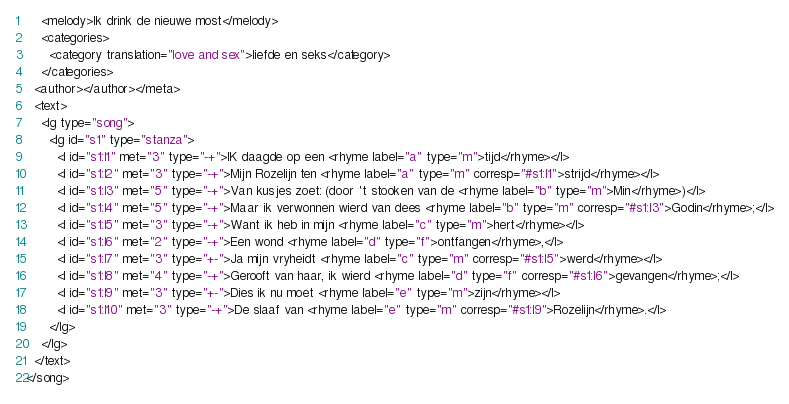<code> <loc_0><loc_0><loc_500><loc_500><_XML_>    <melody>Ik drink de nieuwe most</melody>
    <categories>
      <category translation="love and sex">liefde en seks</category>
    </categories>
  <author></author></meta>
  <text>
    <lg type="song">
      <lg id="s1" type="stanza">
        <l id="s1:l1" met="3" type="-+">IK daagde op een <rhyme label="a" type="m">tijd</rhyme></l>
        <l id="s1:l2" met="3" type="-+">Mijn Rozelijn ten <rhyme label="a" type="m" corresp="#s1:l1">strijd</rhyme></l>
        <l id="s1:l3" met="5" type="-+">Van kusjes zoet: (door 't stooken van de <rhyme label="b" type="m">Min</rhyme>)</l>
        <l id="s1:l4" met="5" type="-+">Maar ik verwonnen wierd van dees <rhyme label="b" type="m" corresp="#s1:l3">Godin</rhyme>;</l>
        <l id="s1:l5" met="3" type="-+">Want ik heb in mijn <rhyme label="c" type="m">hert</rhyme></l>
        <l id="s1:l6" met="2" type="-+">Een wond <rhyme label="d" type="f">ontfangen</rhyme>,</l>
        <l id="s1:l7" met="3" type="+-">Ja mijn vryheidt <rhyme label="c" type="m" corresp="#s1:l5">werd</rhyme></l>
        <l id="s1:l8" met="4" type="-+">Gerooft van haar, ik wierd <rhyme label="d" type="f" corresp="#s1:l6">gevangen</rhyme>;</l>
        <l id="s1:l9" met="3" type="+-">Dies ik nu moet <rhyme label="e" type="m">zijn</rhyme></l>
        <l id="s1:l10" met="3" type="-+">De slaaf van <rhyme label="e" type="m" corresp="#s1:l9">Rozelijn</rhyme>.</l>
      </lg>
    </lg>
  </text>
</song>
</code> 